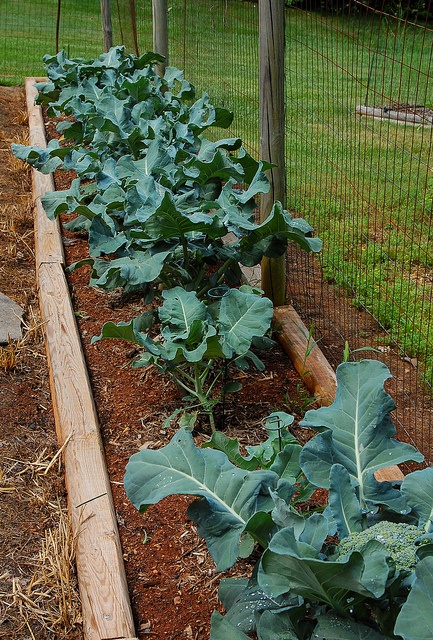Describe the objects in this image and their specific colors. I can see broccoli in darkgreen, black, and teal tones, broccoli in darkgreen, darkgray, and teal tones, and broccoli in darkgreen, black, and teal tones in this image. 